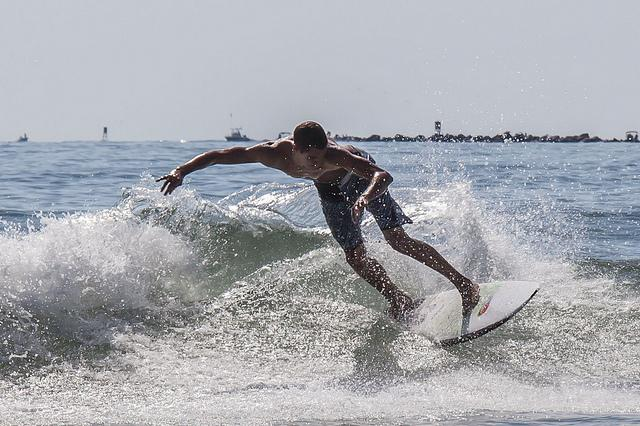Why is he leaning forward? Please explain your reasoning. maintaining balance. The man is trying not to fall. 